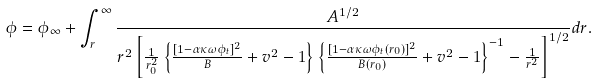Convert formula to latex. <formula><loc_0><loc_0><loc_500><loc_500>\phi = \phi _ { \infty } + \int _ { r } ^ { \infty } { \frac { A ^ { 1 / 2 } } { r ^ { 2 } \left [ \frac { 1 } { r _ { 0 } ^ { 2 } } \left \{ \frac { [ 1 - \alpha \kappa \omega \phi _ { t } ] ^ { 2 } } { B } + v ^ { 2 } - 1 \right \} \left \{ \frac { [ 1 - \alpha \kappa \omega \phi _ { t } ( r _ { 0 } ) ] ^ { 2 } } { B ( r _ { 0 } ) } + v ^ { 2 } - 1 \right \} ^ { - 1 } - \frac { 1 } { r ^ { 2 } } \right ] ^ { 1 / 2 } } } d r .</formula> 